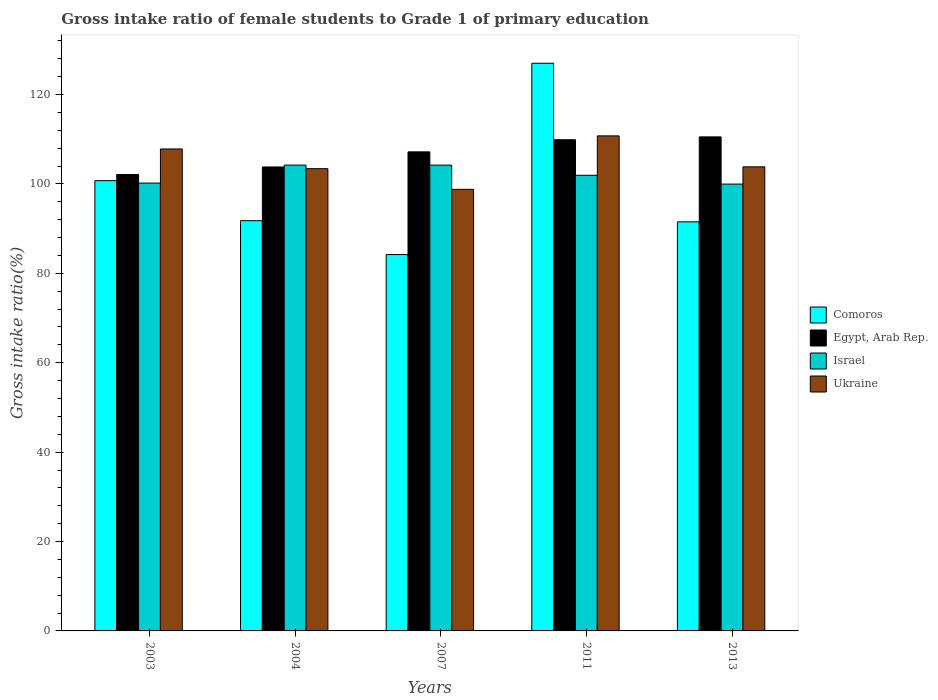How many different coloured bars are there?
Provide a succinct answer. 4. Are the number of bars per tick equal to the number of legend labels?
Give a very brief answer. Yes. Are the number of bars on each tick of the X-axis equal?
Your response must be concise. Yes. How many bars are there on the 2nd tick from the right?
Provide a short and direct response. 4. What is the label of the 4th group of bars from the left?
Ensure brevity in your answer.  2011. In how many cases, is the number of bars for a given year not equal to the number of legend labels?
Your response must be concise. 0. What is the gross intake ratio in Ukraine in 2003?
Ensure brevity in your answer.  107.83. Across all years, what is the maximum gross intake ratio in Egypt, Arab Rep.?
Your answer should be very brief. 110.53. Across all years, what is the minimum gross intake ratio in Egypt, Arab Rep.?
Your answer should be compact. 102.12. In which year was the gross intake ratio in Comoros minimum?
Give a very brief answer. 2007. What is the total gross intake ratio in Ukraine in the graph?
Provide a succinct answer. 524.63. What is the difference between the gross intake ratio in Ukraine in 2004 and that in 2011?
Your answer should be compact. -7.34. What is the difference between the gross intake ratio in Ukraine in 2007 and the gross intake ratio in Israel in 2013?
Offer a very short reply. -1.18. What is the average gross intake ratio in Ukraine per year?
Make the answer very short. 104.93. In the year 2011, what is the difference between the gross intake ratio in Israel and gross intake ratio in Comoros?
Provide a short and direct response. -25.07. What is the ratio of the gross intake ratio in Ukraine in 2003 to that in 2004?
Keep it short and to the point. 1.04. What is the difference between the highest and the second highest gross intake ratio in Comoros?
Offer a terse response. 26.26. What is the difference between the highest and the lowest gross intake ratio in Egypt, Arab Rep.?
Make the answer very short. 8.41. Is the sum of the gross intake ratio in Ukraine in 2007 and 2013 greater than the maximum gross intake ratio in Comoros across all years?
Provide a short and direct response. Yes. Is it the case that in every year, the sum of the gross intake ratio in Ukraine and gross intake ratio in Comoros is greater than the sum of gross intake ratio in Israel and gross intake ratio in Egypt, Arab Rep.?
Provide a succinct answer. Yes. What does the 1st bar from the left in 2011 represents?
Offer a terse response. Comoros. What does the 3rd bar from the right in 2004 represents?
Ensure brevity in your answer.  Egypt, Arab Rep. Is it the case that in every year, the sum of the gross intake ratio in Ukraine and gross intake ratio in Egypt, Arab Rep. is greater than the gross intake ratio in Comoros?
Offer a terse response. Yes. Are all the bars in the graph horizontal?
Your answer should be compact. No. How many years are there in the graph?
Offer a very short reply. 5. What is the difference between two consecutive major ticks on the Y-axis?
Offer a terse response. 20. Are the values on the major ticks of Y-axis written in scientific E-notation?
Provide a short and direct response. No. Does the graph contain grids?
Give a very brief answer. No. How are the legend labels stacked?
Provide a short and direct response. Vertical. What is the title of the graph?
Your answer should be compact. Gross intake ratio of female students to Grade 1 of primary education. Does "Nicaragua" appear as one of the legend labels in the graph?
Make the answer very short. No. What is the label or title of the X-axis?
Provide a short and direct response. Years. What is the label or title of the Y-axis?
Your answer should be compact. Gross intake ratio(%). What is the Gross intake ratio(%) in Comoros in 2003?
Your answer should be compact. 100.74. What is the Gross intake ratio(%) in Egypt, Arab Rep. in 2003?
Your answer should be compact. 102.12. What is the Gross intake ratio(%) of Israel in 2003?
Make the answer very short. 100.2. What is the Gross intake ratio(%) of Ukraine in 2003?
Keep it short and to the point. 107.83. What is the Gross intake ratio(%) in Comoros in 2004?
Your response must be concise. 91.78. What is the Gross intake ratio(%) of Egypt, Arab Rep. in 2004?
Provide a succinct answer. 103.8. What is the Gross intake ratio(%) in Israel in 2004?
Offer a very short reply. 104.22. What is the Gross intake ratio(%) of Ukraine in 2004?
Offer a terse response. 103.42. What is the Gross intake ratio(%) of Comoros in 2007?
Your answer should be compact. 84.2. What is the Gross intake ratio(%) of Egypt, Arab Rep. in 2007?
Provide a short and direct response. 107.18. What is the Gross intake ratio(%) of Israel in 2007?
Your answer should be very brief. 104.22. What is the Gross intake ratio(%) in Ukraine in 2007?
Your answer should be compact. 98.79. What is the Gross intake ratio(%) of Comoros in 2011?
Your response must be concise. 127. What is the Gross intake ratio(%) in Egypt, Arab Rep. in 2011?
Offer a terse response. 109.89. What is the Gross intake ratio(%) of Israel in 2011?
Provide a short and direct response. 101.94. What is the Gross intake ratio(%) of Ukraine in 2011?
Offer a terse response. 110.76. What is the Gross intake ratio(%) of Comoros in 2013?
Keep it short and to the point. 91.52. What is the Gross intake ratio(%) in Egypt, Arab Rep. in 2013?
Your response must be concise. 110.53. What is the Gross intake ratio(%) in Israel in 2013?
Offer a terse response. 99.97. What is the Gross intake ratio(%) of Ukraine in 2013?
Your answer should be compact. 103.83. Across all years, what is the maximum Gross intake ratio(%) of Comoros?
Provide a short and direct response. 127. Across all years, what is the maximum Gross intake ratio(%) of Egypt, Arab Rep.?
Provide a short and direct response. 110.53. Across all years, what is the maximum Gross intake ratio(%) of Israel?
Offer a terse response. 104.22. Across all years, what is the maximum Gross intake ratio(%) in Ukraine?
Ensure brevity in your answer.  110.76. Across all years, what is the minimum Gross intake ratio(%) of Comoros?
Make the answer very short. 84.2. Across all years, what is the minimum Gross intake ratio(%) of Egypt, Arab Rep.?
Ensure brevity in your answer.  102.12. Across all years, what is the minimum Gross intake ratio(%) in Israel?
Ensure brevity in your answer.  99.97. Across all years, what is the minimum Gross intake ratio(%) of Ukraine?
Offer a very short reply. 98.79. What is the total Gross intake ratio(%) in Comoros in the graph?
Give a very brief answer. 495.25. What is the total Gross intake ratio(%) of Egypt, Arab Rep. in the graph?
Your answer should be compact. 533.53. What is the total Gross intake ratio(%) in Israel in the graph?
Ensure brevity in your answer.  510.55. What is the total Gross intake ratio(%) of Ukraine in the graph?
Ensure brevity in your answer.  524.63. What is the difference between the Gross intake ratio(%) of Comoros in 2003 and that in 2004?
Provide a succinct answer. 8.96. What is the difference between the Gross intake ratio(%) of Egypt, Arab Rep. in 2003 and that in 2004?
Your answer should be very brief. -1.68. What is the difference between the Gross intake ratio(%) of Israel in 2003 and that in 2004?
Make the answer very short. -4.02. What is the difference between the Gross intake ratio(%) in Ukraine in 2003 and that in 2004?
Give a very brief answer. 4.41. What is the difference between the Gross intake ratio(%) in Comoros in 2003 and that in 2007?
Your response must be concise. 16.54. What is the difference between the Gross intake ratio(%) of Egypt, Arab Rep. in 2003 and that in 2007?
Offer a very short reply. -5.06. What is the difference between the Gross intake ratio(%) in Israel in 2003 and that in 2007?
Your response must be concise. -4.02. What is the difference between the Gross intake ratio(%) in Ukraine in 2003 and that in 2007?
Keep it short and to the point. 9.04. What is the difference between the Gross intake ratio(%) of Comoros in 2003 and that in 2011?
Your answer should be compact. -26.26. What is the difference between the Gross intake ratio(%) in Egypt, Arab Rep. in 2003 and that in 2011?
Ensure brevity in your answer.  -7.77. What is the difference between the Gross intake ratio(%) of Israel in 2003 and that in 2011?
Offer a terse response. -1.74. What is the difference between the Gross intake ratio(%) of Ukraine in 2003 and that in 2011?
Your response must be concise. -2.93. What is the difference between the Gross intake ratio(%) of Comoros in 2003 and that in 2013?
Offer a very short reply. 9.22. What is the difference between the Gross intake ratio(%) in Egypt, Arab Rep. in 2003 and that in 2013?
Ensure brevity in your answer.  -8.41. What is the difference between the Gross intake ratio(%) in Israel in 2003 and that in 2013?
Your answer should be compact. 0.23. What is the difference between the Gross intake ratio(%) of Ukraine in 2003 and that in 2013?
Provide a short and direct response. 4. What is the difference between the Gross intake ratio(%) of Comoros in 2004 and that in 2007?
Provide a succinct answer. 7.58. What is the difference between the Gross intake ratio(%) of Egypt, Arab Rep. in 2004 and that in 2007?
Offer a terse response. -3.38. What is the difference between the Gross intake ratio(%) in Israel in 2004 and that in 2007?
Keep it short and to the point. 0. What is the difference between the Gross intake ratio(%) of Ukraine in 2004 and that in 2007?
Offer a terse response. 4.63. What is the difference between the Gross intake ratio(%) in Comoros in 2004 and that in 2011?
Offer a very short reply. -35.22. What is the difference between the Gross intake ratio(%) of Egypt, Arab Rep. in 2004 and that in 2011?
Ensure brevity in your answer.  -6.09. What is the difference between the Gross intake ratio(%) of Israel in 2004 and that in 2011?
Keep it short and to the point. 2.28. What is the difference between the Gross intake ratio(%) of Ukraine in 2004 and that in 2011?
Provide a short and direct response. -7.34. What is the difference between the Gross intake ratio(%) of Comoros in 2004 and that in 2013?
Offer a very short reply. 0.26. What is the difference between the Gross intake ratio(%) of Egypt, Arab Rep. in 2004 and that in 2013?
Offer a terse response. -6.73. What is the difference between the Gross intake ratio(%) in Israel in 2004 and that in 2013?
Give a very brief answer. 4.25. What is the difference between the Gross intake ratio(%) of Ukraine in 2004 and that in 2013?
Offer a very short reply. -0.41. What is the difference between the Gross intake ratio(%) in Comoros in 2007 and that in 2011?
Provide a short and direct response. -42.8. What is the difference between the Gross intake ratio(%) in Egypt, Arab Rep. in 2007 and that in 2011?
Offer a terse response. -2.71. What is the difference between the Gross intake ratio(%) of Israel in 2007 and that in 2011?
Your answer should be compact. 2.28. What is the difference between the Gross intake ratio(%) of Ukraine in 2007 and that in 2011?
Give a very brief answer. -11.96. What is the difference between the Gross intake ratio(%) in Comoros in 2007 and that in 2013?
Provide a succinct answer. -7.32. What is the difference between the Gross intake ratio(%) of Egypt, Arab Rep. in 2007 and that in 2013?
Offer a very short reply. -3.35. What is the difference between the Gross intake ratio(%) in Israel in 2007 and that in 2013?
Offer a very short reply. 4.24. What is the difference between the Gross intake ratio(%) in Ukraine in 2007 and that in 2013?
Ensure brevity in your answer.  -5.04. What is the difference between the Gross intake ratio(%) of Comoros in 2011 and that in 2013?
Offer a very short reply. 35.48. What is the difference between the Gross intake ratio(%) of Egypt, Arab Rep. in 2011 and that in 2013?
Your answer should be compact. -0.64. What is the difference between the Gross intake ratio(%) of Israel in 2011 and that in 2013?
Provide a succinct answer. 1.97. What is the difference between the Gross intake ratio(%) of Ukraine in 2011 and that in 2013?
Your answer should be very brief. 6.92. What is the difference between the Gross intake ratio(%) of Comoros in 2003 and the Gross intake ratio(%) of Egypt, Arab Rep. in 2004?
Your response must be concise. -3.06. What is the difference between the Gross intake ratio(%) in Comoros in 2003 and the Gross intake ratio(%) in Israel in 2004?
Offer a very short reply. -3.48. What is the difference between the Gross intake ratio(%) of Comoros in 2003 and the Gross intake ratio(%) of Ukraine in 2004?
Offer a terse response. -2.68. What is the difference between the Gross intake ratio(%) in Egypt, Arab Rep. in 2003 and the Gross intake ratio(%) in Israel in 2004?
Your answer should be very brief. -2.1. What is the difference between the Gross intake ratio(%) in Egypt, Arab Rep. in 2003 and the Gross intake ratio(%) in Ukraine in 2004?
Keep it short and to the point. -1.3. What is the difference between the Gross intake ratio(%) in Israel in 2003 and the Gross intake ratio(%) in Ukraine in 2004?
Ensure brevity in your answer.  -3.22. What is the difference between the Gross intake ratio(%) in Comoros in 2003 and the Gross intake ratio(%) in Egypt, Arab Rep. in 2007?
Offer a terse response. -6.44. What is the difference between the Gross intake ratio(%) of Comoros in 2003 and the Gross intake ratio(%) of Israel in 2007?
Offer a terse response. -3.48. What is the difference between the Gross intake ratio(%) in Comoros in 2003 and the Gross intake ratio(%) in Ukraine in 2007?
Your answer should be very brief. 1.95. What is the difference between the Gross intake ratio(%) of Egypt, Arab Rep. in 2003 and the Gross intake ratio(%) of Israel in 2007?
Give a very brief answer. -2.09. What is the difference between the Gross intake ratio(%) in Egypt, Arab Rep. in 2003 and the Gross intake ratio(%) in Ukraine in 2007?
Your response must be concise. 3.33. What is the difference between the Gross intake ratio(%) in Israel in 2003 and the Gross intake ratio(%) in Ukraine in 2007?
Provide a succinct answer. 1.41. What is the difference between the Gross intake ratio(%) of Comoros in 2003 and the Gross intake ratio(%) of Egypt, Arab Rep. in 2011?
Ensure brevity in your answer.  -9.15. What is the difference between the Gross intake ratio(%) of Comoros in 2003 and the Gross intake ratio(%) of Israel in 2011?
Your response must be concise. -1.2. What is the difference between the Gross intake ratio(%) of Comoros in 2003 and the Gross intake ratio(%) of Ukraine in 2011?
Offer a very short reply. -10.02. What is the difference between the Gross intake ratio(%) of Egypt, Arab Rep. in 2003 and the Gross intake ratio(%) of Israel in 2011?
Give a very brief answer. 0.18. What is the difference between the Gross intake ratio(%) in Egypt, Arab Rep. in 2003 and the Gross intake ratio(%) in Ukraine in 2011?
Make the answer very short. -8.63. What is the difference between the Gross intake ratio(%) of Israel in 2003 and the Gross intake ratio(%) of Ukraine in 2011?
Give a very brief answer. -10.56. What is the difference between the Gross intake ratio(%) of Comoros in 2003 and the Gross intake ratio(%) of Egypt, Arab Rep. in 2013?
Provide a short and direct response. -9.79. What is the difference between the Gross intake ratio(%) in Comoros in 2003 and the Gross intake ratio(%) in Israel in 2013?
Offer a terse response. 0.77. What is the difference between the Gross intake ratio(%) of Comoros in 2003 and the Gross intake ratio(%) of Ukraine in 2013?
Ensure brevity in your answer.  -3.09. What is the difference between the Gross intake ratio(%) of Egypt, Arab Rep. in 2003 and the Gross intake ratio(%) of Israel in 2013?
Offer a very short reply. 2.15. What is the difference between the Gross intake ratio(%) in Egypt, Arab Rep. in 2003 and the Gross intake ratio(%) in Ukraine in 2013?
Your response must be concise. -1.71. What is the difference between the Gross intake ratio(%) in Israel in 2003 and the Gross intake ratio(%) in Ukraine in 2013?
Offer a very short reply. -3.63. What is the difference between the Gross intake ratio(%) in Comoros in 2004 and the Gross intake ratio(%) in Egypt, Arab Rep. in 2007?
Keep it short and to the point. -15.4. What is the difference between the Gross intake ratio(%) of Comoros in 2004 and the Gross intake ratio(%) of Israel in 2007?
Provide a short and direct response. -12.44. What is the difference between the Gross intake ratio(%) in Comoros in 2004 and the Gross intake ratio(%) in Ukraine in 2007?
Your response must be concise. -7.01. What is the difference between the Gross intake ratio(%) of Egypt, Arab Rep. in 2004 and the Gross intake ratio(%) of Israel in 2007?
Make the answer very short. -0.42. What is the difference between the Gross intake ratio(%) of Egypt, Arab Rep. in 2004 and the Gross intake ratio(%) of Ukraine in 2007?
Make the answer very short. 5. What is the difference between the Gross intake ratio(%) in Israel in 2004 and the Gross intake ratio(%) in Ukraine in 2007?
Make the answer very short. 5.43. What is the difference between the Gross intake ratio(%) in Comoros in 2004 and the Gross intake ratio(%) in Egypt, Arab Rep. in 2011?
Provide a short and direct response. -18.11. What is the difference between the Gross intake ratio(%) of Comoros in 2004 and the Gross intake ratio(%) of Israel in 2011?
Make the answer very short. -10.16. What is the difference between the Gross intake ratio(%) in Comoros in 2004 and the Gross intake ratio(%) in Ukraine in 2011?
Give a very brief answer. -18.98. What is the difference between the Gross intake ratio(%) of Egypt, Arab Rep. in 2004 and the Gross intake ratio(%) of Israel in 2011?
Give a very brief answer. 1.86. What is the difference between the Gross intake ratio(%) of Egypt, Arab Rep. in 2004 and the Gross intake ratio(%) of Ukraine in 2011?
Your response must be concise. -6.96. What is the difference between the Gross intake ratio(%) in Israel in 2004 and the Gross intake ratio(%) in Ukraine in 2011?
Your answer should be very brief. -6.54. What is the difference between the Gross intake ratio(%) of Comoros in 2004 and the Gross intake ratio(%) of Egypt, Arab Rep. in 2013?
Offer a very short reply. -18.75. What is the difference between the Gross intake ratio(%) in Comoros in 2004 and the Gross intake ratio(%) in Israel in 2013?
Offer a very short reply. -8.19. What is the difference between the Gross intake ratio(%) of Comoros in 2004 and the Gross intake ratio(%) of Ukraine in 2013?
Keep it short and to the point. -12.05. What is the difference between the Gross intake ratio(%) of Egypt, Arab Rep. in 2004 and the Gross intake ratio(%) of Israel in 2013?
Offer a very short reply. 3.83. What is the difference between the Gross intake ratio(%) of Egypt, Arab Rep. in 2004 and the Gross intake ratio(%) of Ukraine in 2013?
Make the answer very short. -0.03. What is the difference between the Gross intake ratio(%) in Israel in 2004 and the Gross intake ratio(%) in Ukraine in 2013?
Make the answer very short. 0.39. What is the difference between the Gross intake ratio(%) in Comoros in 2007 and the Gross intake ratio(%) in Egypt, Arab Rep. in 2011?
Make the answer very short. -25.69. What is the difference between the Gross intake ratio(%) of Comoros in 2007 and the Gross intake ratio(%) of Israel in 2011?
Your answer should be compact. -17.73. What is the difference between the Gross intake ratio(%) in Comoros in 2007 and the Gross intake ratio(%) in Ukraine in 2011?
Keep it short and to the point. -26.55. What is the difference between the Gross intake ratio(%) in Egypt, Arab Rep. in 2007 and the Gross intake ratio(%) in Israel in 2011?
Your answer should be very brief. 5.24. What is the difference between the Gross intake ratio(%) of Egypt, Arab Rep. in 2007 and the Gross intake ratio(%) of Ukraine in 2011?
Your answer should be very brief. -3.57. What is the difference between the Gross intake ratio(%) of Israel in 2007 and the Gross intake ratio(%) of Ukraine in 2011?
Offer a very short reply. -6.54. What is the difference between the Gross intake ratio(%) of Comoros in 2007 and the Gross intake ratio(%) of Egypt, Arab Rep. in 2013?
Give a very brief answer. -26.33. What is the difference between the Gross intake ratio(%) of Comoros in 2007 and the Gross intake ratio(%) of Israel in 2013?
Ensure brevity in your answer.  -15.77. What is the difference between the Gross intake ratio(%) of Comoros in 2007 and the Gross intake ratio(%) of Ukraine in 2013?
Offer a very short reply. -19.63. What is the difference between the Gross intake ratio(%) of Egypt, Arab Rep. in 2007 and the Gross intake ratio(%) of Israel in 2013?
Ensure brevity in your answer.  7.21. What is the difference between the Gross intake ratio(%) of Egypt, Arab Rep. in 2007 and the Gross intake ratio(%) of Ukraine in 2013?
Offer a very short reply. 3.35. What is the difference between the Gross intake ratio(%) in Israel in 2007 and the Gross intake ratio(%) in Ukraine in 2013?
Offer a terse response. 0.38. What is the difference between the Gross intake ratio(%) of Comoros in 2011 and the Gross intake ratio(%) of Egypt, Arab Rep. in 2013?
Keep it short and to the point. 16.47. What is the difference between the Gross intake ratio(%) in Comoros in 2011 and the Gross intake ratio(%) in Israel in 2013?
Your response must be concise. 27.03. What is the difference between the Gross intake ratio(%) in Comoros in 2011 and the Gross intake ratio(%) in Ukraine in 2013?
Ensure brevity in your answer.  23.17. What is the difference between the Gross intake ratio(%) in Egypt, Arab Rep. in 2011 and the Gross intake ratio(%) in Israel in 2013?
Ensure brevity in your answer.  9.92. What is the difference between the Gross intake ratio(%) of Egypt, Arab Rep. in 2011 and the Gross intake ratio(%) of Ukraine in 2013?
Make the answer very short. 6.06. What is the difference between the Gross intake ratio(%) in Israel in 2011 and the Gross intake ratio(%) in Ukraine in 2013?
Give a very brief answer. -1.89. What is the average Gross intake ratio(%) in Comoros per year?
Your answer should be compact. 99.05. What is the average Gross intake ratio(%) in Egypt, Arab Rep. per year?
Provide a succinct answer. 106.71. What is the average Gross intake ratio(%) in Israel per year?
Provide a short and direct response. 102.11. What is the average Gross intake ratio(%) in Ukraine per year?
Ensure brevity in your answer.  104.93. In the year 2003, what is the difference between the Gross intake ratio(%) in Comoros and Gross intake ratio(%) in Egypt, Arab Rep.?
Keep it short and to the point. -1.38. In the year 2003, what is the difference between the Gross intake ratio(%) of Comoros and Gross intake ratio(%) of Israel?
Your answer should be very brief. 0.54. In the year 2003, what is the difference between the Gross intake ratio(%) in Comoros and Gross intake ratio(%) in Ukraine?
Offer a terse response. -7.09. In the year 2003, what is the difference between the Gross intake ratio(%) of Egypt, Arab Rep. and Gross intake ratio(%) of Israel?
Offer a very short reply. 1.92. In the year 2003, what is the difference between the Gross intake ratio(%) of Egypt, Arab Rep. and Gross intake ratio(%) of Ukraine?
Provide a short and direct response. -5.71. In the year 2003, what is the difference between the Gross intake ratio(%) of Israel and Gross intake ratio(%) of Ukraine?
Ensure brevity in your answer.  -7.63. In the year 2004, what is the difference between the Gross intake ratio(%) in Comoros and Gross intake ratio(%) in Egypt, Arab Rep.?
Ensure brevity in your answer.  -12.02. In the year 2004, what is the difference between the Gross intake ratio(%) in Comoros and Gross intake ratio(%) in Israel?
Provide a short and direct response. -12.44. In the year 2004, what is the difference between the Gross intake ratio(%) of Comoros and Gross intake ratio(%) of Ukraine?
Keep it short and to the point. -11.64. In the year 2004, what is the difference between the Gross intake ratio(%) of Egypt, Arab Rep. and Gross intake ratio(%) of Israel?
Offer a terse response. -0.42. In the year 2004, what is the difference between the Gross intake ratio(%) in Egypt, Arab Rep. and Gross intake ratio(%) in Ukraine?
Provide a succinct answer. 0.38. In the year 2004, what is the difference between the Gross intake ratio(%) in Israel and Gross intake ratio(%) in Ukraine?
Ensure brevity in your answer.  0.8. In the year 2007, what is the difference between the Gross intake ratio(%) in Comoros and Gross intake ratio(%) in Egypt, Arab Rep.?
Keep it short and to the point. -22.98. In the year 2007, what is the difference between the Gross intake ratio(%) in Comoros and Gross intake ratio(%) in Israel?
Your answer should be very brief. -20.01. In the year 2007, what is the difference between the Gross intake ratio(%) of Comoros and Gross intake ratio(%) of Ukraine?
Make the answer very short. -14.59. In the year 2007, what is the difference between the Gross intake ratio(%) in Egypt, Arab Rep. and Gross intake ratio(%) in Israel?
Your answer should be very brief. 2.97. In the year 2007, what is the difference between the Gross intake ratio(%) of Egypt, Arab Rep. and Gross intake ratio(%) of Ukraine?
Give a very brief answer. 8.39. In the year 2007, what is the difference between the Gross intake ratio(%) in Israel and Gross intake ratio(%) in Ukraine?
Your answer should be very brief. 5.42. In the year 2011, what is the difference between the Gross intake ratio(%) of Comoros and Gross intake ratio(%) of Egypt, Arab Rep.?
Give a very brief answer. 17.11. In the year 2011, what is the difference between the Gross intake ratio(%) in Comoros and Gross intake ratio(%) in Israel?
Make the answer very short. 25.07. In the year 2011, what is the difference between the Gross intake ratio(%) of Comoros and Gross intake ratio(%) of Ukraine?
Provide a succinct answer. 16.25. In the year 2011, what is the difference between the Gross intake ratio(%) in Egypt, Arab Rep. and Gross intake ratio(%) in Israel?
Your answer should be compact. 7.95. In the year 2011, what is the difference between the Gross intake ratio(%) in Egypt, Arab Rep. and Gross intake ratio(%) in Ukraine?
Your response must be concise. -0.86. In the year 2011, what is the difference between the Gross intake ratio(%) in Israel and Gross intake ratio(%) in Ukraine?
Your answer should be compact. -8.82. In the year 2013, what is the difference between the Gross intake ratio(%) of Comoros and Gross intake ratio(%) of Egypt, Arab Rep.?
Provide a short and direct response. -19.01. In the year 2013, what is the difference between the Gross intake ratio(%) in Comoros and Gross intake ratio(%) in Israel?
Ensure brevity in your answer.  -8.45. In the year 2013, what is the difference between the Gross intake ratio(%) in Comoros and Gross intake ratio(%) in Ukraine?
Your answer should be very brief. -12.31. In the year 2013, what is the difference between the Gross intake ratio(%) in Egypt, Arab Rep. and Gross intake ratio(%) in Israel?
Give a very brief answer. 10.56. In the year 2013, what is the difference between the Gross intake ratio(%) of Egypt, Arab Rep. and Gross intake ratio(%) of Ukraine?
Your response must be concise. 6.7. In the year 2013, what is the difference between the Gross intake ratio(%) in Israel and Gross intake ratio(%) in Ukraine?
Provide a succinct answer. -3.86. What is the ratio of the Gross intake ratio(%) of Comoros in 2003 to that in 2004?
Keep it short and to the point. 1.1. What is the ratio of the Gross intake ratio(%) in Egypt, Arab Rep. in 2003 to that in 2004?
Provide a succinct answer. 0.98. What is the ratio of the Gross intake ratio(%) of Israel in 2003 to that in 2004?
Your answer should be compact. 0.96. What is the ratio of the Gross intake ratio(%) in Ukraine in 2003 to that in 2004?
Make the answer very short. 1.04. What is the ratio of the Gross intake ratio(%) in Comoros in 2003 to that in 2007?
Give a very brief answer. 1.2. What is the ratio of the Gross intake ratio(%) of Egypt, Arab Rep. in 2003 to that in 2007?
Ensure brevity in your answer.  0.95. What is the ratio of the Gross intake ratio(%) of Israel in 2003 to that in 2007?
Offer a terse response. 0.96. What is the ratio of the Gross intake ratio(%) in Ukraine in 2003 to that in 2007?
Keep it short and to the point. 1.09. What is the ratio of the Gross intake ratio(%) of Comoros in 2003 to that in 2011?
Keep it short and to the point. 0.79. What is the ratio of the Gross intake ratio(%) in Egypt, Arab Rep. in 2003 to that in 2011?
Your answer should be very brief. 0.93. What is the ratio of the Gross intake ratio(%) of Israel in 2003 to that in 2011?
Offer a terse response. 0.98. What is the ratio of the Gross intake ratio(%) in Ukraine in 2003 to that in 2011?
Your answer should be very brief. 0.97. What is the ratio of the Gross intake ratio(%) of Comoros in 2003 to that in 2013?
Your answer should be very brief. 1.1. What is the ratio of the Gross intake ratio(%) of Egypt, Arab Rep. in 2003 to that in 2013?
Offer a terse response. 0.92. What is the ratio of the Gross intake ratio(%) in Israel in 2003 to that in 2013?
Provide a short and direct response. 1. What is the ratio of the Gross intake ratio(%) of Ukraine in 2003 to that in 2013?
Provide a succinct answer. 1.04. What is the ratio of the Gross intake ratio(%) of Comoros in 2004 to that in 2007?
Your answer should be compact. 1.09. What is the ratio of the Gross intake ratio(%) in Egypt, Arab Rep. in 2004 to that in 2007?
Your answer should be very brief. 0.97. What is the ratio of the Gross intake ratio(%) of Israel in 2004 to that in 2007?
Your answer should be very brief. 1. What is the ratio of the Gross intake ratio(%) in Ukraine in 2004 to that in 2007?
Provide a succinct answer. 1.05. What is the ratio of the Gross intake ratio(%) in Comoros in 2004 to that in 2011?
Your answer should be compact. 0.72. What is the ratio of the Gross intake ratio(%) of Egypt, Arab Rep. in 2004 to that in 2011?
Your response must be concise. 0.94. What is the ratio of the Gross intake ratio(%) in Israel in 2004 to that in 2011?
Offer a terse response. 1.02. What is the ratio of the Gross intake ratio(%) in Ukraine in 2004 to that in 2011?
Make the answer very short. 0.93. What is the ratio of the Gross intake ratio(%) of Comoros in 2004 to that in 2013?
Provide a succinct answer. 1. What is the ratio of the Gross intake ratio(%) of Egypt, Arab Rep. in 2004 to that in 2013?
Your answer should be very brief. 0.94. What is the ratio of the Gross intake ratio(%) of Israel in 2004 to that in 2013?
Provide a short and direct response. 1.04. What is the ratio of the Gross intake ratio(%) in Ukraine in 2004 to that in 2013?
Give a very brief answer. 1. What is the ratio of the Gross intake ratio(%) of Comoros in 2007 to that in 2011?
Your response must be concise. 0.66. What is the ratio of the Gross intake ratio(%) in Egypt, Arab Rep. in 2007 to that in 2011?
Give a very brief answer. 0.98. What is the ratio of the Gross intake ratio(%) in Israel in 2007 to that in 2011?
Provide a succinct answer. 1.02. What is the ratio of the Gross intake ratio(%) in Ukraine in 2007 to that in 2011?
Keep it short and to the point. 0.89. What is the ratio of the Gross intake ratio(%) in Comoros in 2007 to that in 2013?
Your answer should be compact. 0.92. What is the ratio of the Gross intake ratio(%) of Egypt, Arab Rep. in 2007 to that in 2013?
Ensure brevity in your answer.  0.97. What is the ratio of the Gross intake ratio(%) in Israel in 2007 to that in 2013?
Keep it short and to the point. 1.04. What is the ratio of the Gross intake ratio(%) in Ukraine in 2007 to that in 2013?
Offer a terse response. 0.95. What is the ratio of the Gross intake ratio(%) in Comoros in 2011 to that in 2013?
Your answer should be very brief. 1.39. What is the ratio of the Gross intake ratio(%) in Israel in 2011 to that in 2013?
Offer a terse response. 1.02. What is the ratio of the Gross intake ratio(%) in Ukraine in 2011 to that in 2013?
Provide a short and direct response. 1.07. What is the difference between the highest and the second highest Gross intake ratio(%) of Comoros?
Your answer should be compact. 26.26. What is the difference between the highest and the second highest Gross intake ratio(%) in Egypt, Arab Rep.?
Provide a succinct answer. 0.64. What is the difference between the highest and the second highest Gross intake ratio(%) of Israel?
Your answer should be compact. 0. What is the difference between the highest and the second highest Gross intake ratio(%) in Ukraine?
Provide a succinct answer. 2.93. What is the difference between the highest and the lowest Gross intake ratio(%) in Comoros?
Give a very brief answer. 42.8. What is the difference between the highest and the lowest Gross intake ratio(%) in Egypt, Arab Rep.?
Your answer should be very brief. 8.41. What is the difference between the highest and the lowest Gross intake ratio(%) in Israel?
Offer a terse response. 4.25. What is the difference between the highest and the lowest Gross intake ratio(%) in Ukraine?
Your answer should be very brief. 11.96. 